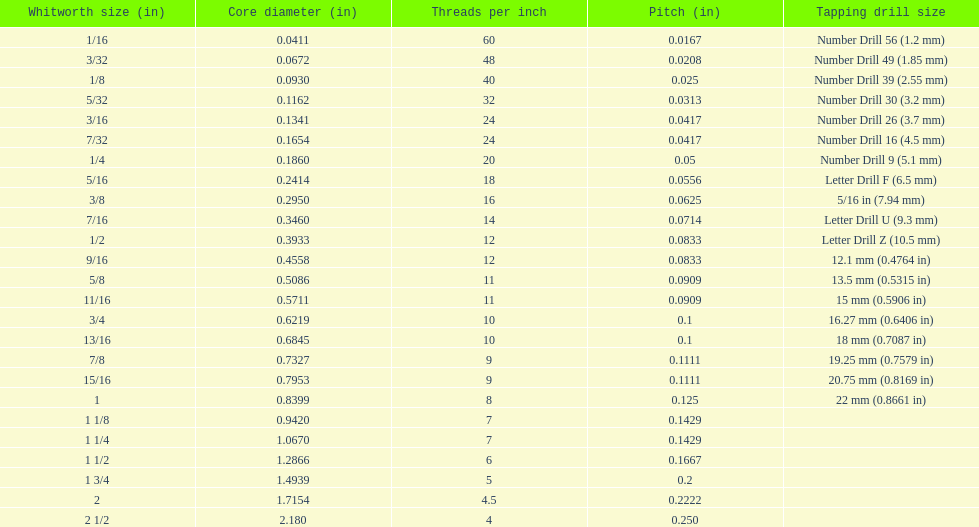In inches, what is the minimum core diameter? 0.0411. 